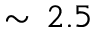Convert formula to latex. <formula><loc_0><loc_0><loc_500><loc_500>\sim \, 2 . 5</formula> 